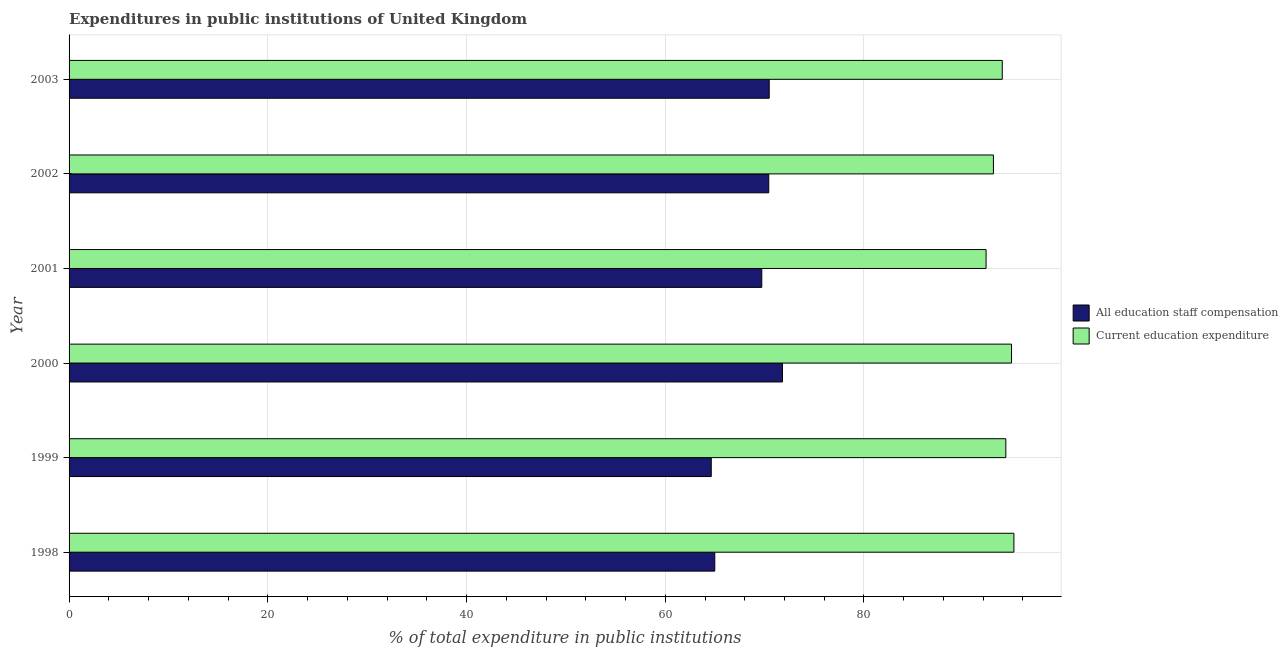How many groups of bars are there?
Your answer should be very brief. 6. Are the number of bars per tick equal to the number of legend labels?
Give a very brief answer. Yes. Are the number of bars on each tick of the Y-axis equal?
Your response must be concise. Yes. How many bars are there on the 2nd tick from the top?
Provide a succinct answer. 2. How many bars are there on the 1st tick from the bottom?
Your response must be concise. 2. What is the expenditure in education in 2000?
Offer a very short reply. 94.85. Across all years, what is the maximum expenditure in staff compensation?
Your answer should be very brief. 71.8. Across all years, what is the minimum expenditure in staff compensation?
Make the answer very short. 64.63. In which year was the expenditure in staff compensation maximum?
Your response must be concise. 2000. In which year was the expenditure in education minimum?
Your answer should be very brief. 2001. What is the total expenditure in staff compensation in the graph?
Provide a short and direct response. 412.01. What is the difference between the expenditure in education in 2001 and that in 2003?
Offer a very short reply. -1.63. What is the difference between the expenditure in staff compensation in 1999 and the expenditure in education in 1998?
Make the answer very short. -30.46. What is the average expenditure in education per year?
Your answer should be compact. 93.91. In the year 2000, what is the difference between the expenditure in staff compensation and expenditure in education?
Your answer should be very brief. -23.05. In how many years, is the expenditure in staff compensation greater than 68 %?
Your answer should be very brief. 4. Is the expenditure in staff compensation in 1999 less than that in 2001?
Provide a succinct answer. Yes. Is the difference between the expenditure in staff compensation in 2001 and 2003 greater than the difference between the expenditure in education in 2001 and 2003?
Keep it short and to the point. Yes. What is the difference between the highest and the second highest expenditure in staff compensation?
Ensure brevity in your answer.  1.34. What is the difference between the highest and the lowest expenditure in education?
Give a very brief answer. 2.8. Is the sum of the expenditure in staff compensation in 1998 and 2002 greater than the maximum expenditure in education across all years?
Offer a very short reply. Yes. What does the 2nd bar from the top in 1999 represents?
Provide a succinct answer. All education staff compensation. What does the 2nd bar from the bottom in 2001 represents?
Make the answer very short. Current education expenditure. How many bars are there?
Make the answer very short. 12. How many years are there in the graph?
Your answer should be compact. 6. Does the graph contain any zero values?
Your answer should be compact. No. Where does the legend appear in the graph?
Your answer should be compact. Center right. How many legend labels are there?
Your answer should be very brief. 2. How are the legend labels stacked?
Your response must be concise. Vertical. What is the title of the graph?
Offer a terse response. Expenditures in public institutions of United Kingdom. What is the label or title of the X-axis?
Make the answer very short. % of total expenditure in public institutions. What is the label or title of the Y-axis?
Your answer should be compact. Year. What is the % of total expenditure in public institutions in All education staff compensation in 1998?
Provide a short and direct response. 64.98. What is the % of total expenditure in public institutions of Current education expenditure in 1998?
Offer a very short reply. 95.09. What is the % of total expenditure in public institutions in All education staff compensation in 1999?
Give a very brief answer. 64.63. What is the % of total expenditure in public institutions in Current education expenditure in 1999?
Your answer should be compact. 94.28. What is the % of total expenditure in public institutions in All education staff compensation in 2000?
Your answer should be compact. 71.8. What is the % of total expenditure in public institutions in Current education expenditure in 2000?
Provide a succinct answer. 94.85. What is the % of total expenditure in public institutions of All education staff compensation in 2001?
Your response must be concise. 69.72. What is the % of total expenditure in public institutions of Current education expenditure in 2001?
Keep it short and to the point. 92.29. What is the % of total expenditure in public institutions in All education staff compensation in 2002?
Make the answer very short. 70.42. What is the % of total expenditure in public institutions in Current education expenditure in 2002?
Offer a very short reply. 93.03. What is the % of total expenditure in public institutions of All education staff compensation in 2003?
Offer a very short reply. 70.46. What is the % of total expenditure in public institutions in Current education expenditure in 2003?
Keep it short and to the point. 93.92. Across all years, what is the maximum % of total expenditure in public institutions of All education staff compensation?
Keep it short and to the point. 71.8. Across all years, what is the maximum % of total expenditure in public institutions of Current education expenditure?
Offer a very short reply. 95.09. Across all years, what is the minimum % of total expenditure in public institutions in All education staff compensation?
Give a very brief answer. 64.63. Across all years, what is the minimum % of total expenditure in public institutions of Current education expenditure?
Offer a terse response. 92.29. What is the total % of total expenditure in public institutions of All education staff compensation in the graph?
Make the answer very short. 412.01. What is the total % of total expenditure in public institutions in Current education expenditure in the graph?
Provide a short and direct response. 563.45. What is the difference between the % of total expenditure in public institutions of All education staff compensation in 1998 and that in 1999?
Ensure brevity in your answer.  0.35. What is the difference between the % of total expenditure in public institutions of Current education expenditure in 1998 and that in 1999?
Provide a short and direct response. 0.81. What is the difference between the % of total expenditure in public institutions of All education staff compensation in 1998 and that in 2000?
Your response must be concise. -6.82. What is the difference between the % of total expenditure in public institutions of Current education expenditure in 1998 and that in 2000?
Your answer should be compact. 0.24. What is the difference between the % of total expenditure in public institutions in All education staff compensation in 1998 and that in 2001?
Offer a terse response. -4.73. What is the difference between the % of total expenditure in public institutions of Current education expenditure in 1998 and that in 2001?
Make the answer very short. 2.8. What is the difference between the % of total expenditure in public institutions of All education staff compensation in 1998 and that in 2002?
Your answer should be compact. -5.43. What is the difference between the % of total expenditure in public institutions in Current education expenditure in 1998 and that in 2002?
Make the answer very short. 2.06. What is the difference between the % of total expenditure in public institutions in All education staff compensation in 1998 and that in 2003?
Give a very brief answer. -5.48. What is the difference between the % of total expenditure in public institutions in Current education expenditure in 1998 and that in 2003?
Ensure brevity in your answer.  1.17. What is the difference between the % of total expenditure in public institutions of All education staff compensation in 1999 and that in 2000?
Provide a short and direct response. -7.17. What is the difference between the % of total expenditure in public institutions in Current education expenditure in 1999 and that in 2000?
Offer a terse response. -0.57. What is the difference between the % of total expenditure in public institutions of All education staff compensation in 1999 and that in 2001?
Your answer should be compact. -5.08. What is the difference between the % of total expenditure in public institutions of Current education expenditure in 1999 and that in 2001?
Your answer should be very brief. 1.99. What is the difference between the % of total expenditure in public institutions in All education staff compensation in 1999 and that in 2002?
Give a very brief answer. -5.79. What is the difference between the % of total expenditure in public institutions in Current education expenditure in 1999 and that in 2002?
Your answer should be compact. 1.25. What is the difference between the % of total expenditure in public institutions of All education staff compensation in 1999 and that in 2003?
Your response must be concise. -5.83. What is the difference between the % of total expenditure in public institutions of Current education expenditure in 1999 and that in 2003?
Your answer should be compact. 0.36. What is the difference between the % of total expenditure in public institutions in All education staff compensation in 2000 and that in 2001?
Make the answer very short. 2.09. What is the difference between the % of total expenditure in public institutions in Current education expenditure in 2000 and that in 2001?
Keep it short and to the point. 2.56. What is the difference between the % of total expenditure in public institutions of All education staff compensation in 2000 and that in 2002?
Provide a short and direct response. 1.38. What is the difference between the % of total expenditure in public institutions in Current education expenditure in 2000 and that in 2002?
Give a very brief answer. 1.82. What is the difference between the % of total expenditure in public institutions in All education staff compensation in 2000 and that in 2003?
Your response must be concise. 1.34. What is the difference between the % of total expenditure in public institutions of Current education expenditure in 2000 and that in 2003?
Your answer should be compact. 0.93. What is the difference between the % of total expenditure in public institutions of All education staff compensation in 2001 and that in 2002?
Provide a succinct answer. -0.7. What is the difference between the % of total expenditure in public institutions of Current education expenditure in 2001 and that in 2002?
Keep it short and to the point. -0.74. What is the difference between the % of total expenditure in public institutions in All education staff compensation in 2001 and that in 2003?
Ensure brevity in your answer.  -0.75. What is the difference between the % of total expenditure in public institutions in Current education expenditure in 2001 and that in 2003?
Give a very brief answer. -1.63. What is the difference between the % of total expenditure in public institutions of All education staff compensation in 2002 and that in 2003?
Your answer should be very brief. -0.05. What is the difference between the % of total expenditure in public institutions of Current education expenditure in 2002 and that in 2003?
Ensure brevity in your answer.  -0.89. What is the difference between the % of total expenditure in public institutions of All education staff compensation in 1998 and the % of total expenditure in public institutions of Current education expenditure in 1999?
Provide a succinct answer. -29.29. What is the difference between the % of total expenditure in public institutions in All education staff compensation in 1998 and the % of total expenditure in public institutions in Current education expenditure in 2000?
Offer a very short reply. -29.87. What is the difference between the % of total expenditure in public institutions of All education staff compensation in 1998 and the % of total expenditure in public institutions of Current education expenditure in 2001?
Provide a succinct answer. -27.3. What is the difference between the % of total expenditure in public institutions in All education staff compensation in 1998 and the % of total expenditure in public institutions in Current education expenditure in 2002?
Offer a terse response. -28.04. What is the difference between the % of total expenditure in public institutions in All education staff compensation in 1998 and the % of total expenditure in public institutions in Current education expenditure in 2003?
Give a very brief answer. -28.93. What is the difference between the % of total expenditure in public institutions of All education staff compensation in 1999 and the % of total expenditure in public institutions of Current education expenditure in 2000?
Your answer should be very brief. -30.22. What is the difference between the % of total expenditure in public institutions of All education staff compensation in 1999 and the % of total expenditure in public institutions of Current education expenditure in 2001?
Offer a very short reply. -27.66. What is the difference between the % of total expenditure in public institutions of All education staff compensation in 1999 and the % of total expenditure in public institutions of Current education expenditure in 2002?
Offer a terse response. -28.4. What is the difference between the % of total expenditure in public institutions in All education staff compensation in 1999 and the % of total expenditure in public institutions in Current education expenditure in 2003?
Your response must be concise. -29.29. What is the difference between the % of total expenditure in public institutions in All education staff compensation in 2000 and the % of total expenditure in public institutions in Current education expenditure in 2001?
Offer a very short reply. -20.49. What is the difference between the % of total expenditure in public institutions in All education staff compensation in 2000 and the % of total expenditure in public institutions in Current education expenditure in 2002?
Make the answer very short. -21.23. What is the difference between the % of total expenditure in public institutions of All education staff compensation in 2000 and the % of total expenditure in public institutions of Current education expenditure in 2003?
Ensure brevity in your answer.  -22.12. What is the difference between the % of total expenditure in public institutions in All education staff compensation in 2001 and the % of total expenditure in public institutions in Current education expenditure in 2002?
Make the answer very short. -23.31. What is the difference between the % of total expenditure in public institutions in All education staff compensation in 2001 and the % of total expenditure in public institutions in Current education expenditure in 2003?
Give a very brief answer. -24.2. What is the difference between the % of total expenditure in public institutions of All education staff compensation in 2002 and the % of total expenditure in public institutions of Current education expenditure in 2003?
Give a very brief answer. -23.5. What is the average % of total expenditure in public institutions of All education staff compensation per year?
Your answer should be compact. 68.67. What is the average % of total expenditure in public institutions of Current education expenditure per year?
Give a very brief answer. 93.91. In the year 1998, what is the difference between the % of total expenditure in public institutions of All education staff compensation and % of total expenditure in public institutions of Current education expenditure?
Your answer should be very brief. -30.1. In the year 1999, what is the difference between the % of total expenditure in public institutions of All education staff compensation and % of total expenditure in public institutions of Current education expenditure?
Make the answer very short. -29.65. In the year 2000, what is the difference between the % of total expenditure in public institutions of All education staff compensation and % of total expenditure in public institutions of Current education expenditure?
Ensure brevity in your answer.  -23.05. In the year 2001, what is the difference between the % of total expenditure in public institutions in All education staff compensation and % of total expenditure in public institutions in Current education expenditure?
Provide a succinct answer. -22.57. In the year 2002, what is the difference between the % of total expenditure in public institutions of All education staff compensation and % of total expenditure in public institutions of Current education expenditure?
Provide a succinct answer. -22.61. In the year 2003, what is the difference between the % of total expenditure in public institutions in All education staff compensation and % of total expenditure in public institutions in Current education expenditure?
Provide a short and direct response. -23.45. What is the ratio of the % of total expenditure in public institutions in All education staff compensation in 1998 to that in 1999?
Make the answer very short. 1.01. What is the ratio of the % of total expenditure in public institutions in Current education expenditure in 1998 to that in 1999?
Keep it short and to the point. 1.01. What is the ratio of the % of total expenditure in public institutions of All education staff compensation in 1998 to that in 2000?
Provide a short and direct response. 0.91. What is the ratio of the % of total expenditure in public institutions in Current education expenditure in 1998 to that in 2000?
Ensure brevity in your answer.  1. What is the ratio of the % of total expenditure in public institutions in All education staff compensation in 1998 to that in 2001?
Your answer should be compact. 0.93. What is the ratio of the % of total expenditure in public institutions of Current education expenditure in 1998 to that in 2001?
Give a very brief answer. 1.03. What is the ratio of the % of total expenditure in public institutions of All education staff compensation in 1998 to that in 2002?
Offer a terse response. 0.92. What is the ratio of the % of total expenditure in public institutions of Current education expenditure in 1998 to that in 2002?
Offer a terse response. 1.02. What is the ratio of the % of total expenditure in public institutions of All education staff compensation in 1998 to that in 2003?
Your answer should be very brief. 0.92. What is the ratio of the % of total expenditure in public institutions in Current education expenditure in 1998 to that in 2003?
Your answer should be very brief. 1.01. What is the ratio of the % of total expenditure in public institutions in All education staff compensation in 1999 to that in 2000?
Offer a very short reply. 0.9. What is the ratio of the % of total expenditure in public institutions in Current education expenditure in 1999 to that in 2000?
Offer a very short reply. 0.99. What is the ratio of the % of total expenditure in public institutions in All education staff compensation in 1999 to that in 2001?
Your response must be concise. 0.93. What is the ratio of the % of total expenditure in public institutions of Current education expenditure in 1999 to that in 2001?
Give a very brief answer. 1.02. What is the ratio of the % of total expenditure in public institutions of All education staff compensation in 1999 to that in 2002?
Provide a succinct answer. 0.92. What is the ratio of the % of total expenditure in public institutions of Current education expenditure in 1999 to that in 2002?
Ensure brevity in your answer.  1.01. What is the ratio of the % of total expenditure in public institutions in All education staff compensation in 1999 to that in 2003?
Keep it short and to the point. 0.92. What is the ratio of the % of total expenditure in public institutions in Current education expenditure in 1999 to that in 2003?
Provide a succinct answer. 1. What is the ratio of the % of total expenditure in public institutions of All education staff compensation in 2000 to that in 2001?
Your answer should be very brief. 1.03. What is the ratio of the % of total expenditure in public institutions in Current education expenditure in 2000 to that in 2001?
Keep it short and to the point. 1.03. What is the ratio of the % of total expenditure in public institutions in All education staff compensation in 2000 to that in 2002?
Your answer should be very brief. 1.02. What is the ratio of the % of total expenditure in public institutions of Current education expenditure in 2000 to that in 2002?
Ensure brevity in your answer.  1.02. What is the ratio of the % of total expenditure in public institutions in Current education expenditure in 2000 to that in 2003?
Your answer should be compact. 1.01. What is the ratio of the % of total expenditure in public institutions of All education staff compensation in 2001 to that in 2002?
Ensure brevity in your answer.  0.99. What is the ratio of the % of total expenditure in public institutions of All education staff compensation in 2001 to that in 2003?
Make the answer very short. 0.99. What is the ratio of the % of total expenditure in public institutions in Current education expenditure in 2001 to that in 2003?
Ensure brevity in your answer.  0.98. What is the ratio of the % of total expenditure in public institutions in Current education expenditure in 2002 to that in 2003?
Offer a terse response. 0.99. What is the difference between the highest and the second highest % of total expenditure in public institutions of All education staff compensation?
Make the answer very short. 1.34. What is the difference between the highest and the second highest % of total expenditure in public institutions in Current education expenditure?
Provide a short and direct response. 0.24. What is the difference between the highest and the lowest % of total expenditure in public institutions of All education staff compensation?
Provide a short and direct response. 7.17. What is the difference between the highest and the lowest % of total expenditure in public institutions of Current education expenditure?
Your response must be concise. 2.8. 